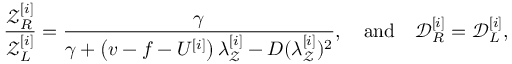Convert formula to latex. <formula><loc_0><loc_0><loc_500><loc_500>\frac { \mathcal { Z } _ { R } ^ { [ i ] } } { \mathcal { Z } _ { L } ^ { [ i ] } } = \frac { \gamma } { \gamma + \left ( v - f - U ^ { [ i ] } \right ) \lambda _ { \mathcal { Z } } ^ { [ i ] } - D ( \lambda _ { \mathcal { Z } } ^ { [ i ] } ) ^ { 2 } } , \quad a n d \quad \mathcal { D } _ { R } ^ { [ i ] } = \mathcal { D } _ { L } ^ { [ i ] } ,</formula> 